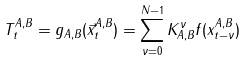<formula> <loc_0><loc_0><loc_500><loc_500>T _ { t } ^ { A , B } = g _ { A , B } ( \vec { x } _ { t } ^ { A , B } ) = \sum _ { \nu = 0 } ^ { N - 1 } { K _ { A , B } ^ { \nu } f ( x ^ { A , B } _ { t - \nu } ) }</formula> 